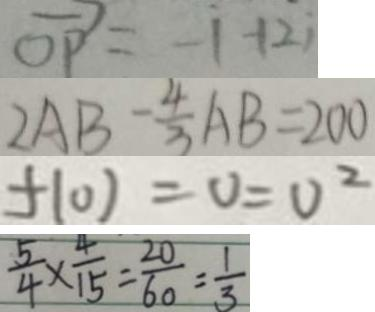Convert formula to latex. <formula><loc_0><loc_0><loc_500><loc_500>\overrightarrow { O P } = - 1 + 2 i 
 2 A B - \frac { 4 } { 3 } A B = 2 0 0 
 f ( 0 ) = 0 = 0 ^ { 2 } 
 \frac { 5 } { 4 } \times \frac { 4 } { 1 5 } = \frac { 2 0 } { 6 0 } = \frac { 1 } { 3 }</formula> 